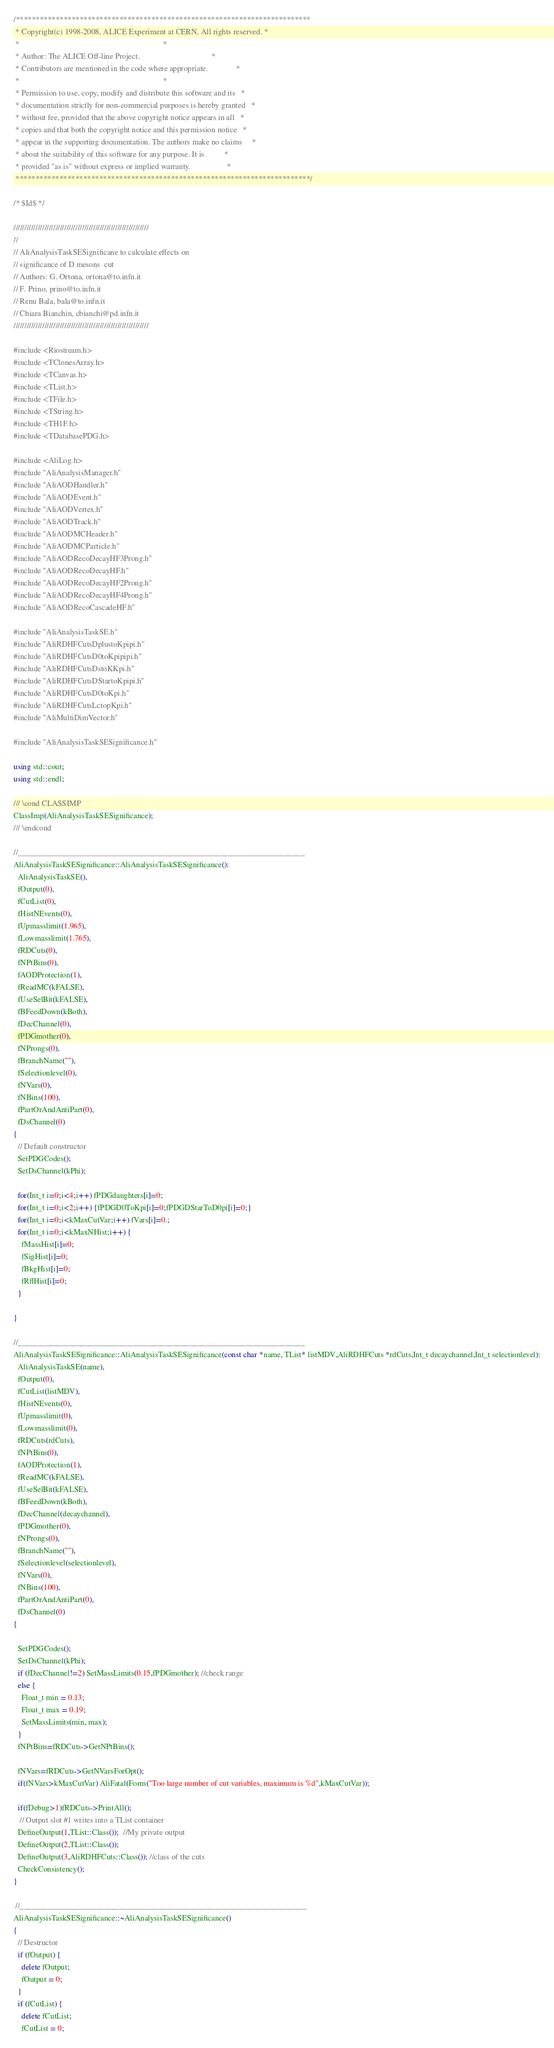Convert code to text. <code><loc_0><loc_0><loc_500><loc_500><_C++_>/**************************************************************************
 * Copyright(c) 1998-2008, ALICE Experiment at CERN, All rights reserved. *
 *                                                                        *
 * Author: The ALICE Off-line Project.                                    *
 * Contributors are mentioned in the code where appropriate.              *
 *                                                                        *
 * Permission to use, copy, modify and distribute this software and its   *
 * documentation strictly for non-commercial purposes is hereby granted   *
 * without fee, provided that the above copyright notice appears in all   *
 * copies and that both the copyright notice and this permission notice   *
 * appear in the supporting documentation. The authors make no claims     *
 * about the suitability of this software for any purpose. It is          *
 * provided "as is" without express or implied warranty.                  *
 **************************************************************************/

/* $Id$ */

/////////////////////////////////////////////////////////////
//
// AliAnalysisTaskSESignificane to calculate effects on 
// significance of D mesons  cut 
// Authors: G. Ortona, ortona@to.infn.it
// F. Prino, prino@to.infn.it
// Renu Bala, bala@to.infn.it
// Chiara Bianchin, cbianchi@pd.infn.it
/////////////////////////////////////////////////////////////

#include <Riostream.h>
#include <TClonesArray.h>
#include <TCanvas.h>
#include <TList.h>
#include <TFile.h>
#include <TString.h>
#include <TH1F.h>
#include <TDatabasePDG.h>

#include <AliLog.h>
#include "AliAnalysisManager.h"
#include "AliAODHandler.h"
#include "AliAODEvent.h"
#include "AliAODVertex.h"
#include "AliAODTrack.h"
#include "AliAODMCHeader.h"
#include "AliAODMCParticle.h"
#include "AliAODRecoDecayHF3Prong.h"
#include "AliAODRecoDecayHF.h"
#include "AliAODRecoDecayHF2Prong.h"
#include "AliAODRecoDecayHF4Prong.h"
#include "AliAODRecoCascadeHF.h"

#include "AliAnalysisTaskSE.h"
#include "AliRDHFCutsDplustoKpipi.h"
#include "AliRDHFCutsD0toKpipipi.h"
#include "AliRDHFCutsDstoKKpi.h"
#include "AliRDHFCutsDStartoKpipi.h"
#include "AliRDHFCutsD0toKpi.h"
#include "AliRDHFCutsLctopKpi.h"
#include "AliMultiDimVector.h"

#include "AliAnalysisTaskSESignificance.h"

using std::cout;
using std::endl;

/// \cond CLASSIMP
ClassImp(AliAnalysisTaskSESignificance);
/// \endcond

//________________________________________________________________________
AliAnalysisTaskSESignificance::AliAnalysisTaskSESignificance():
  AliAnalysisTaskSE(),
  fOutput(0),
  fCutList(0),
  fHistNEvents(0),
  fUpmasslimit(1.965),
  fLowmasslimit(1.765),
  fRDCuts(0),
  fNPtBins(0),
  fAODProtection(1),
  fReadMC(kFALSE),
  fUseSelBit(kFALSE),
  fBFeedDown(kBoth),
  fDecChannel(0),
  fPDGmother(0),
  fNProngs(0),
  fBranchName(""),
  fSelectionlevel(0),
  fNVars(0),
  fNBins(100),
  fPartOrAndAntiPart(0),
  fDsChannel(0)
{
  // Default constructor
  SetPDGCodes();
  SetDsChannel(kPhi);

  for(Int_t i=0;i<4;i++) fPDGdaughters[i]=0;
  for(Int_t i=0;i<2;i++) {fPDGD0ToKpi[i]=0;fPDGDStarToD0pi[i]=0;}
  for(Int_t i=0;i<kMaxCutVar;i++) fVars[i]=0.;
  for(Int_t i=0;i<kMaxNHist;i++) {
    fMassHist[i]=0;
    fSigHist[i]=0;
    fBkgHist[i]=0;
    fRflHist[i]=0;
  }

}

//________________________________________________________________________
AliAnalysisTaskSESignificance::AliAnalysisTaskSESignificance(const char *name, TList* listMDV,AliRDHFCuts *rdCuts,Int_t decaychannel,Int_t selectionlevel):
  AliAnalysisTaskSE(name),
  fOutput(0),
  fCutList(listMDV),
  fHistNEvents(0),
  fUpmasslimit(0),
  fLowmasslimit(0),
  fRDCuts(rdCuts),
  fNPtBins(0),
  fAODProtection(1),
  fReadMC(kFALSE),
  fUseSelBit(kFALSE),
  fBFeedDown(kBoth),
  fDecChannel(decaychannel),
  fPDGmother(0),
  fNProngs(0),
  fBranchName(""),
  fSelectionlevel(selectionlevel),
  fNVars(0),
  fNBins(100),
  fPartOrAndAntiPart(0),
  fDsChannel(0)
{

  SetPDGCodes();
  SetDsChannel(kPhi);
  if (fDecChannel!=2) SetMassLimits(0.15,fPDGmother); //check range
  else {
    Float_t min = 0.13;
    Float_t max = 0.19;
    SetMassLimits(min, max);
  }
  fNPtBins=fRDCuts->GetNPtBins();

  fNVars=fRDCuts->GetNVarsForOpt();
  if(fNVars>kMaxCutVar) AliFatal(Form("Too large number of cut variables, maximum is %d",kMaxCutVar));
  
  if(fDebug>1)fRDCuts->PrintAll();
   // Output slot #1 writes into a TList container
  DefineOutput(1,TList::Class());  //My private output
  DefineOutput(2,TList::Class());
  DefineOutput(3,AliRDHFCuts::Class()); //class of the cuts
  CheckConsistency();
}

 //________________________________________________________________________
AliAnalysisTaskSESignificance::~AliAnalysisTaskSESignificance()
{
  // Destructor
  if (fOutput) {
    delete fOutput;
    fOutput = 0;
  }
  if (fCutList) {
    delete fCutList;
    fCutList = 0;</code> 